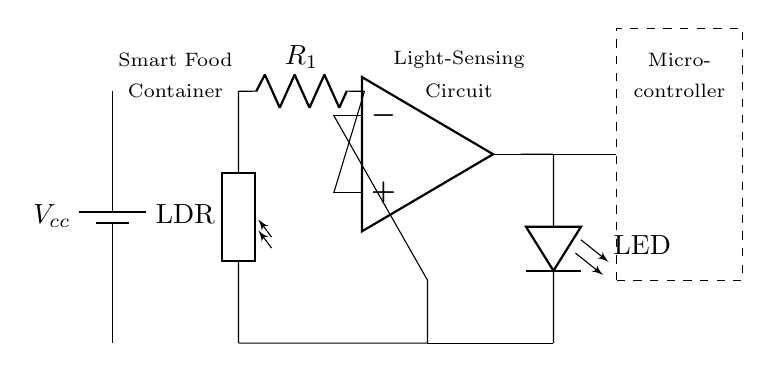What component is used to sense light? The light sensing component used in this circuit is a photoresistor, also known as an LDR. This is indicated in the circuit diagram where the label "LDR" is shown next to the respective symbol.
Answer: photoresistor What is the purpose of the operational amplifier in this circuit? The operational amplifier is used to amplify the signal coming from the light sensor. The input from the light sensor is fed into the op-amp to process and amplify it, allowing for better detection of light variation.
Answer: amplify How many resistors are present in the circuit? There is one resistor labeled as "R1" in this circuit. This can be seen from the diagram where a resistor symbol is used with the identifier "R1."
Answer: one What is the function of the LED in this circuit? The LED in this circuit serves as a visual indicator of freshness based on the light detected by the sensor; it lights up when the conditions are met as per the circuit's design.
Answer: visual indicator What does the dashed box represent in the diagram? The dashed box represents the microcontroller, which processes the signals from the operational amplifier and makes decisions based on the input from the light sensor, controlling the LED accordingly.
Answer: microcontroller How would you describe the type of circuit shown? This circuit can be described as a light-sensing circuit designed specifically for a smart food storage container to monitor freshness. It employs a sensor, an amplifier, and an indicator within a compact structure to fulfill its function.
Answer: light-sensing circuit 